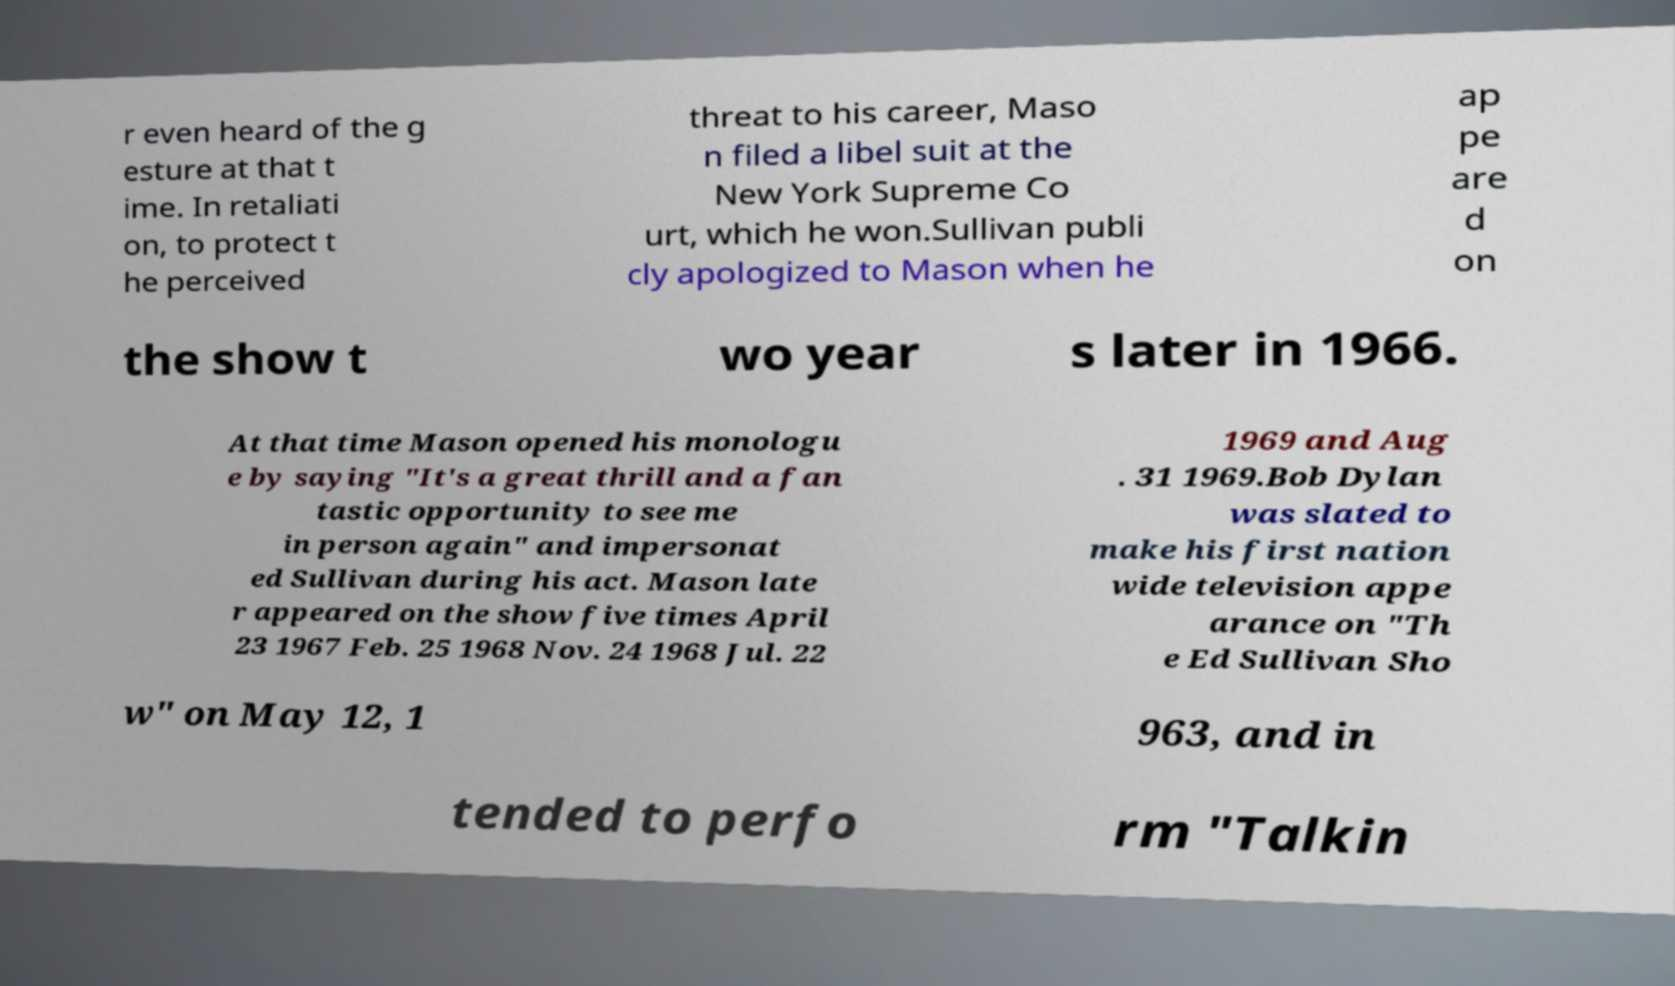Could you assist in decoding the text presented in this image and type it out clearly? r even heard of the g esture at that t ime. In retaliati on, to protect t he perceived threat to his career, Maso n filed a libel suit at the New York Supreme Co urt, which he won.Sullivan publi cly apologized to Mason when he ap pe are d on the show t wo year s later in 1966. At that time Mason opened his monologu e by saying "It's a great thrill and a fan tastic opportunity to see me in person again" and impersonat ed Sullivan during his act. Mason late r appeared on the show five times April 23 1967 Feb. 25 1968 Nov. 24 1968 Jul. 22 1969 and Aug . 31 1969.Bob Dylan was slated to make his first nation wide television appe arance on "Th e Ed Sullivan Sho w" on May 12, 1 963, and in tended to perfo rm "Talkin 